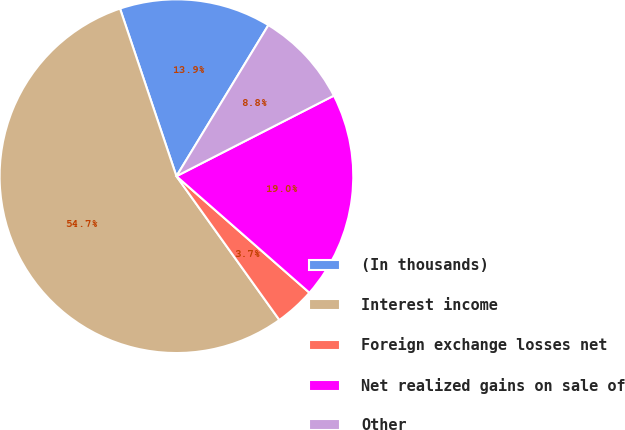Convert chart to OTSL. <chart><loc_0><loc_0><loc_500><loc_500><pie_chart><fcel>(In thousands)<fcel>Interest income<fcel>Foreign exchange losses net<fcel>Net realized gains on sale of<fcel>Other<nl><fcel>13.87%<fcel>54.72%<fcel>3.66%<fcel>18.98%<fcel>8.77%<nl></chart> 